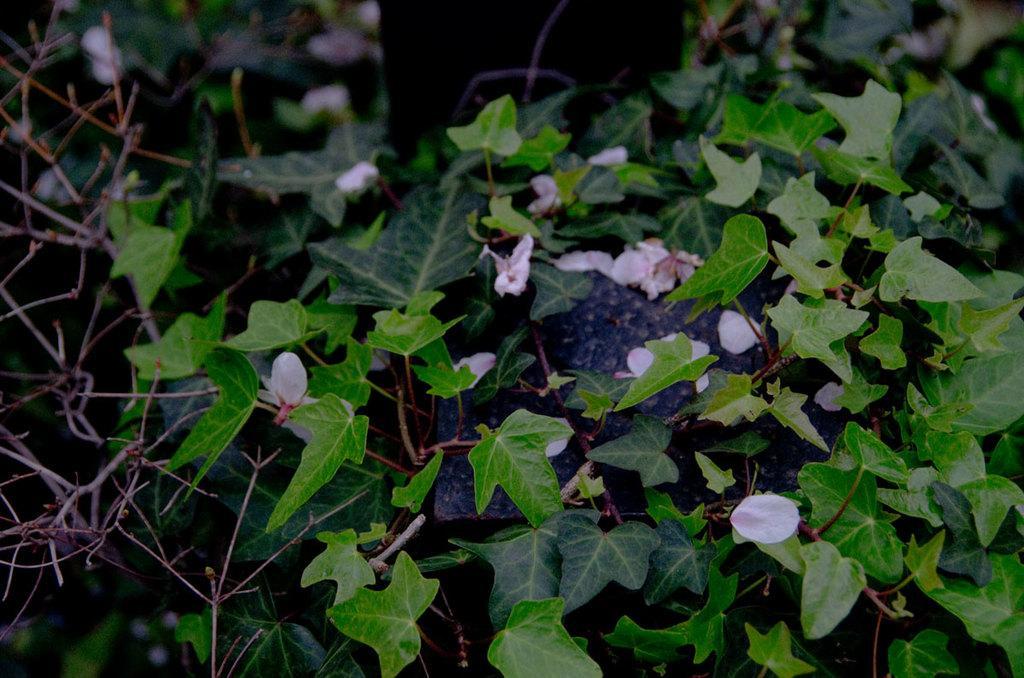Please provide a concise description of this image. In this image we can see pink color flowers, leaves and stems. 